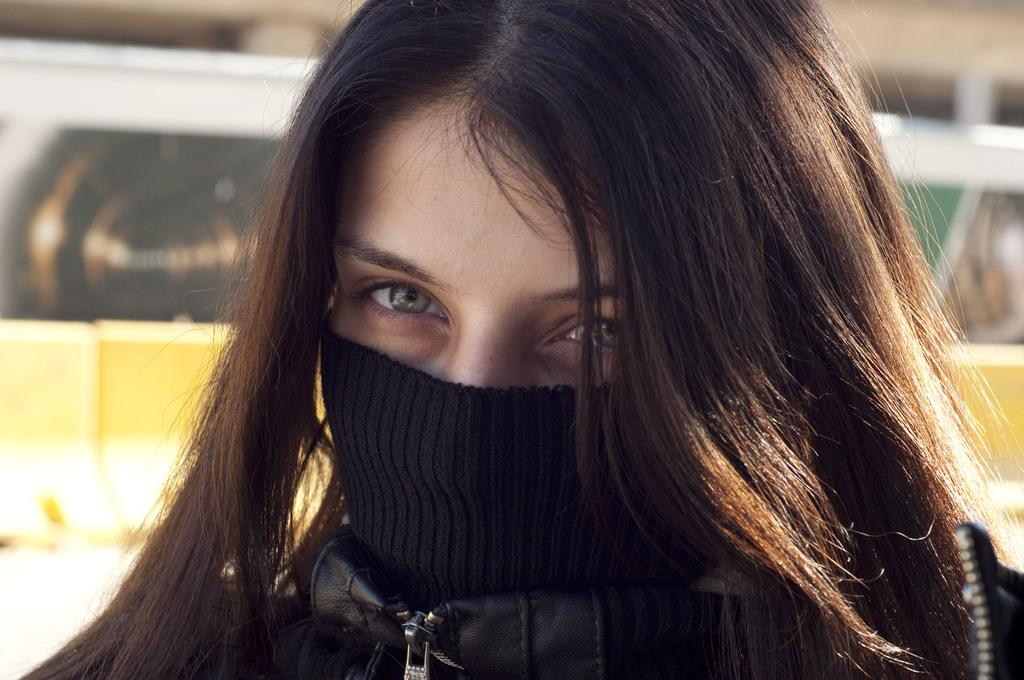Who is present in the image? There is a woman in the image. What is the woman doing in the image? The woman is watching something. Can you describe the woman's appearance in the image? The woman is wearing a mask. How would you describe the background of the image? The background is blurred. What type of alarm can be heard in the image? There is no alarm present in the image; it is a still image with no sound. 